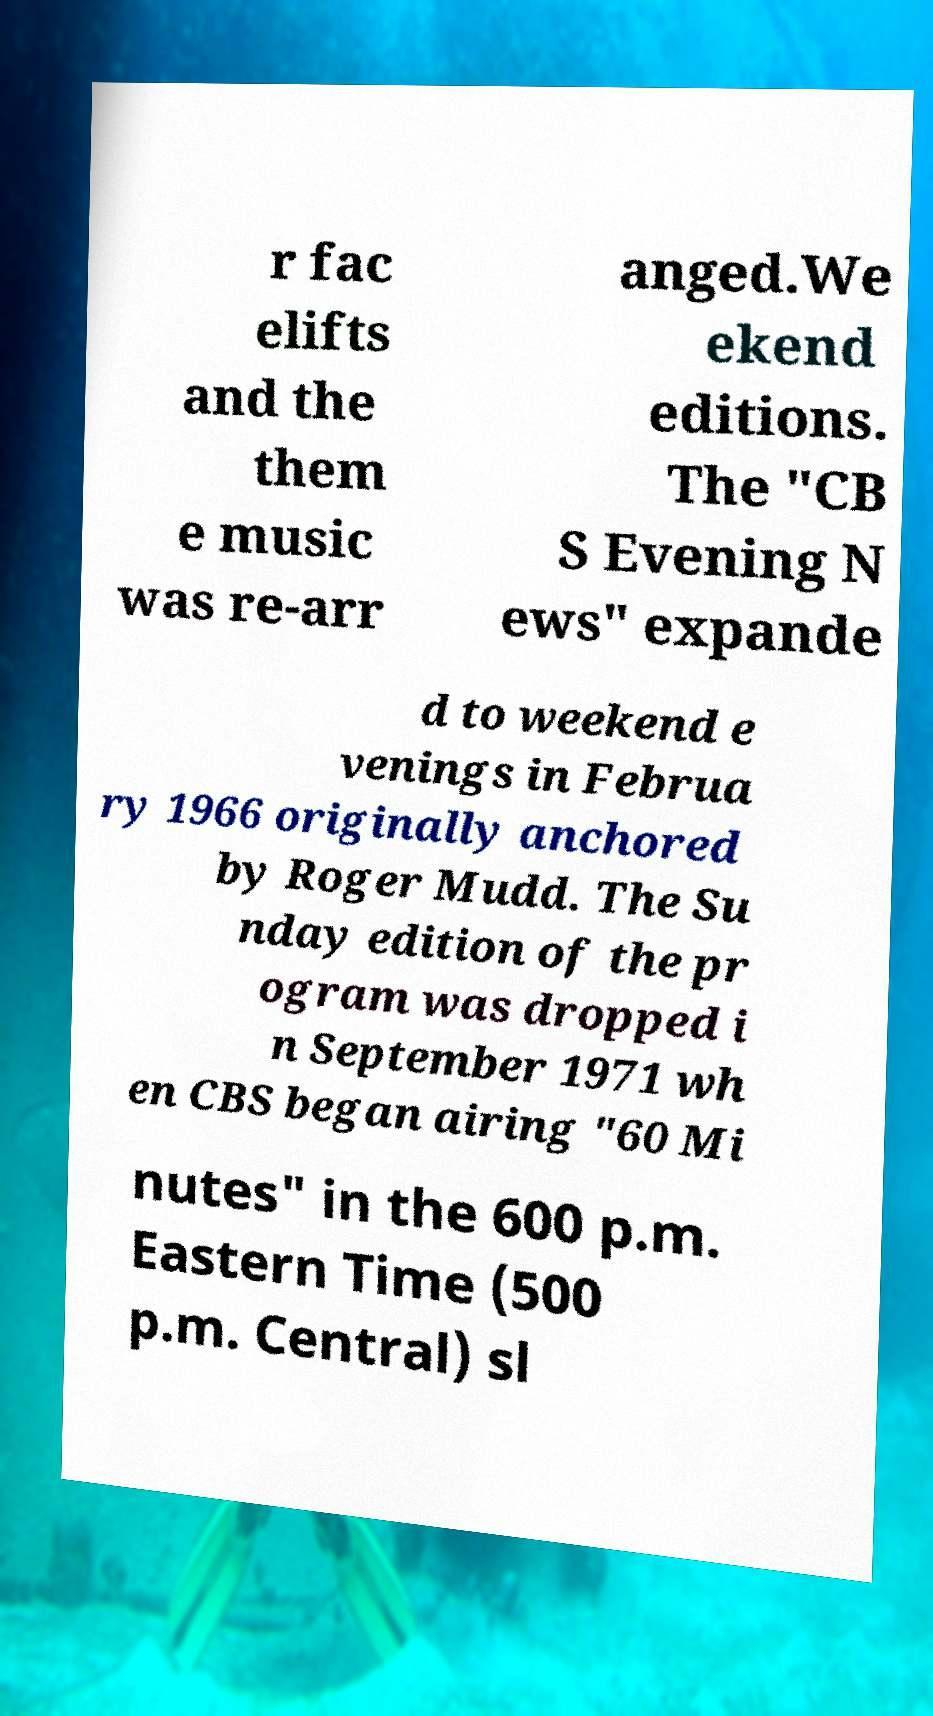I need the written content from this picture converted into text. Can you do that? r fac elifts and the them e music was re-arr anged.We ekend editions. The "CB S Evening N ews" expande d to weekend e venings in Februa ry 1966 originally anchored by Roger Mudd. The Su nday edition of the pr ogram was dropped i n September 1971 wh en CBS began airing "60 Mi nutes" in the 600 p.m. Eastern Time (500 p.m. Central) sl 